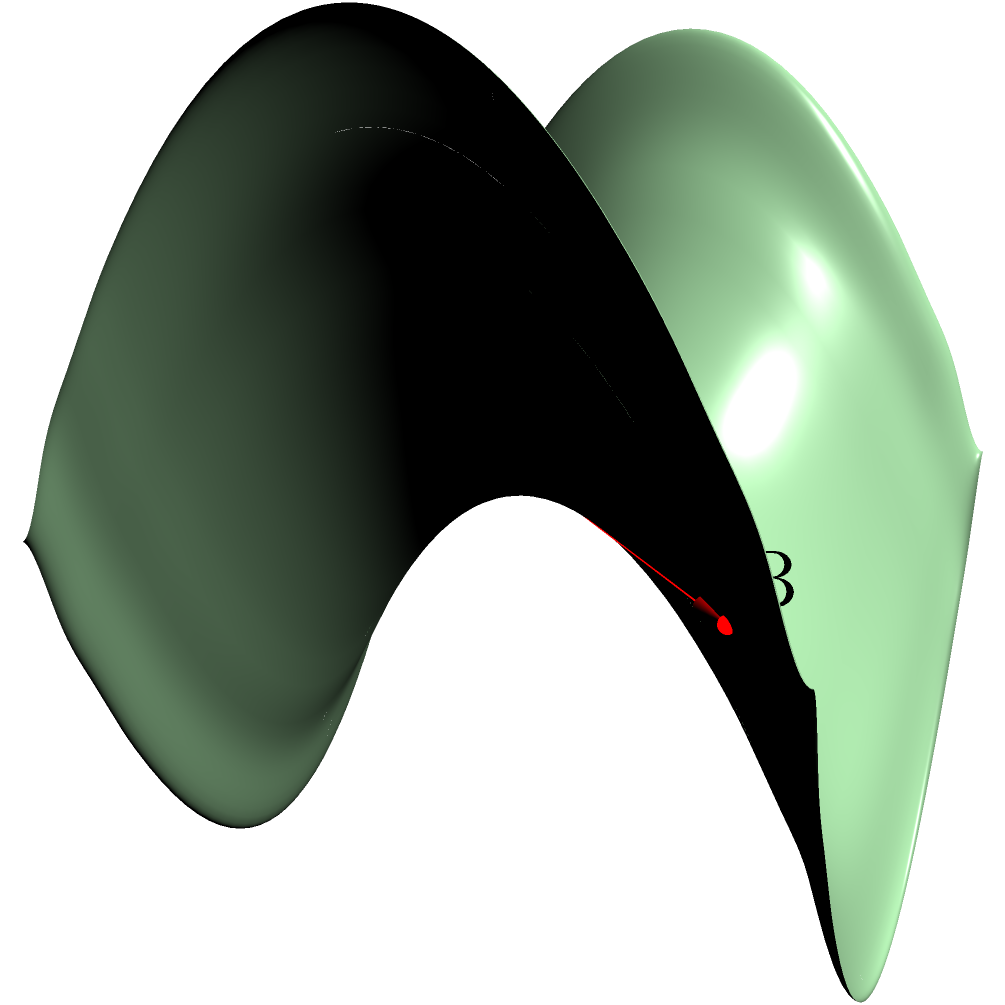As an amateur ethnographer studying the traditional navigation methods of a remote island culture, you come across a unique map drawn on a saddle-shaped surface. The islanders claim that the shortest path between two points on this map is not always a straight line. Consider points A and B on the saddle-shaped surface as shown in the diagram. Which path represents the true shortest distance between these points: the straight red line or the curved blue line? To understand this problem, we need to consider the principles of non-Euclidean geometry, specifically geometry on a saddle-shaped surface (hyperbolic geometry):

1. In Euclidean geometry (flat surfaces), the shortest path between two points is always a straight line.

2. However, on curved surfaces like a saddle, this is not necessarily true. The shortest path between two points on such a surface is called a geodesic.

3. A saddle-shaped surface has negative curvature, meaning it curves upward in one direction and downward in the perpendicular direction.

4. On a saddle surface, geodesics tend to curve away from the center of the saddle.

5. In the given diagram:
   - The red line represents a straight path in 3D space, but it doesn't follow the curvature of the surface.
   - The blue curve follows the surface's curvature and represents a geodesic on the saddle.

6. Although the blue curve looks longer in 3D space, it actually represents the shortest path along the surface between points A and B.

7. This is because the blue curve minimizes the distance traveled on the actual surface, while the red line would require "leaving" the surface to travel in a straight line.

Therefore, the curved blue line represents the true shortest distance between points A and B on this saddle-shaped surface.
Answer: The curved blue line 